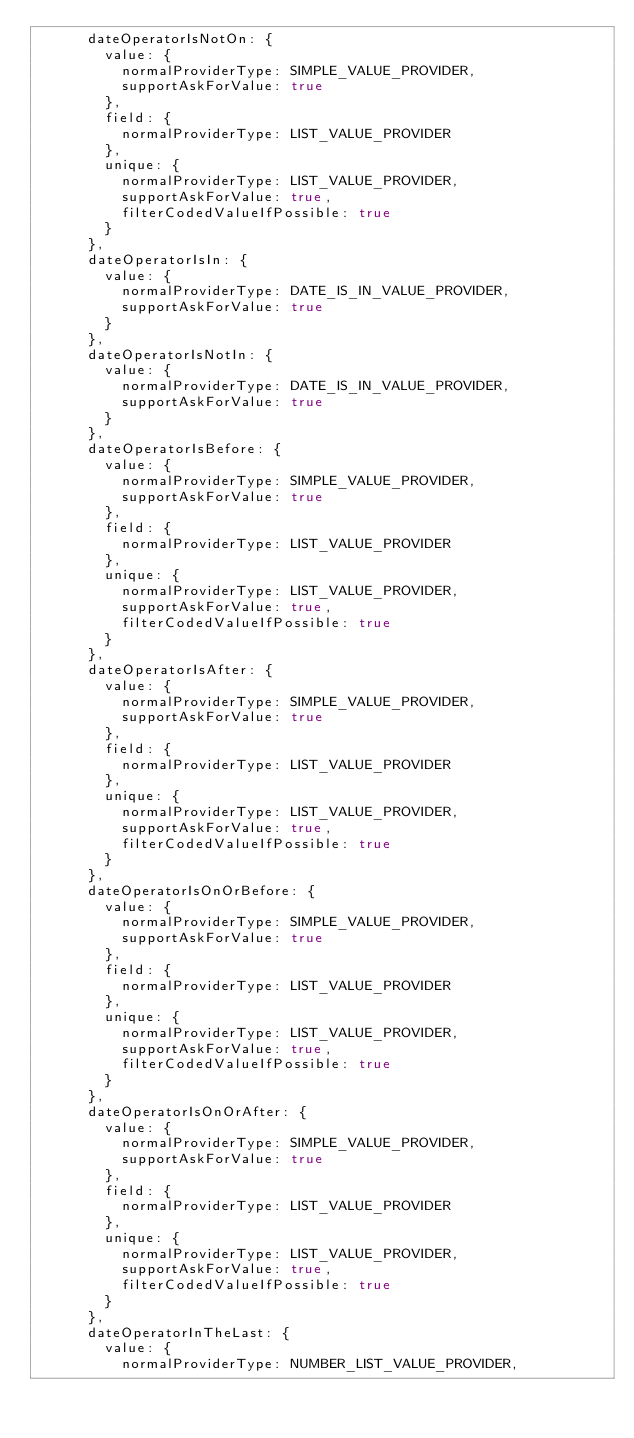<code> <loc_0><loc_0><loc_500><loc_500><_JavaScript_>      dateOperatorIsNotOn: {
        value: {
          normalProviderType: SIMPLE_VALUE_PROVIDER,
          supportAskForValue: true
        },
        field: {
          normalProviderType: LIST_VALUE_PROVIDER
        },
        unique: {
          normalProviderType: LIST_VALUE_PROVIDER,
          supportAskForValue: true,
          filterCodedValueIfPossible: true
        }
      },
      dateOperatorIsIn: {
        value: {
          normalProviderType: DATE_IS_IN_VALUE_PROVIDER,
          supportAskForValue: true
        }
      },
      dateOperatorIsNotIn: {
        value: {
          normalProviderType: DATE_IS_IN_VALUE_PROVIDER,
          supportAskForValue: true
        }
      },
      dateOperatorIsBefore: {
        value: {
          normalProviderType: SIMPLE_VALUE_PROVIDER,
          supportAskForValue: true
        },
        field: {
          normalProviderType: LIST_VALUE_PROVIDER
        },
        unique: {
          normalProviderType: LIST_VALUE_PROVIDER,
          supportAskForValue: true,
          filterCodedValueIfPossible: true
        }
      },
      dateOperatorIsAfter: {
        value: {
          normalProviderType: SIMPLE_VALUE_PROVIDER,
          supportAskForValue: true
        },
        field: {
          normalProviderType: LIST_VALUE_PROVIDER
        },
        unique: {
          normalProviderType: LIST_VALUE_PROVIDER,
          supportAskForValue: true,
          filterCodedValueIfPossible: true
        }
      },
      dateOperatorIsOnOrBefore: {
        value: {
          normalProviderType: SIMPLE_VALUE_PROVIDER,
          supportAskForValue: true
        },
        field: {
          normalProviderType: LIST_VALUE_PROVIDER
        },
        unique: {
          normalProviderType: LIST_VALUE_PROVIDER,
          supportAskForValue: true,
          filterCodedValueIfPossible: true
        }
      },
      dateOperatorIsOnOrAfter: {
        value: {
          normalProviderType: SIMPLE_VALUE_PROVIDER,
          supportAskForValue: true
        },
        field: {
          normalProviderType: LIST_VALUE_PROVIDER
        },
        unique: {
          normalProviderType: LIST_VALUE_PROVIDER,
          supportAskForValue: true,
          filterCodedValueIfPossible: true
        }
      },
      dateOperatorInTheLast: {
        value: {
          normalProviderType: NUMBER_LIST_VALUE_PROVIDER,</code> 